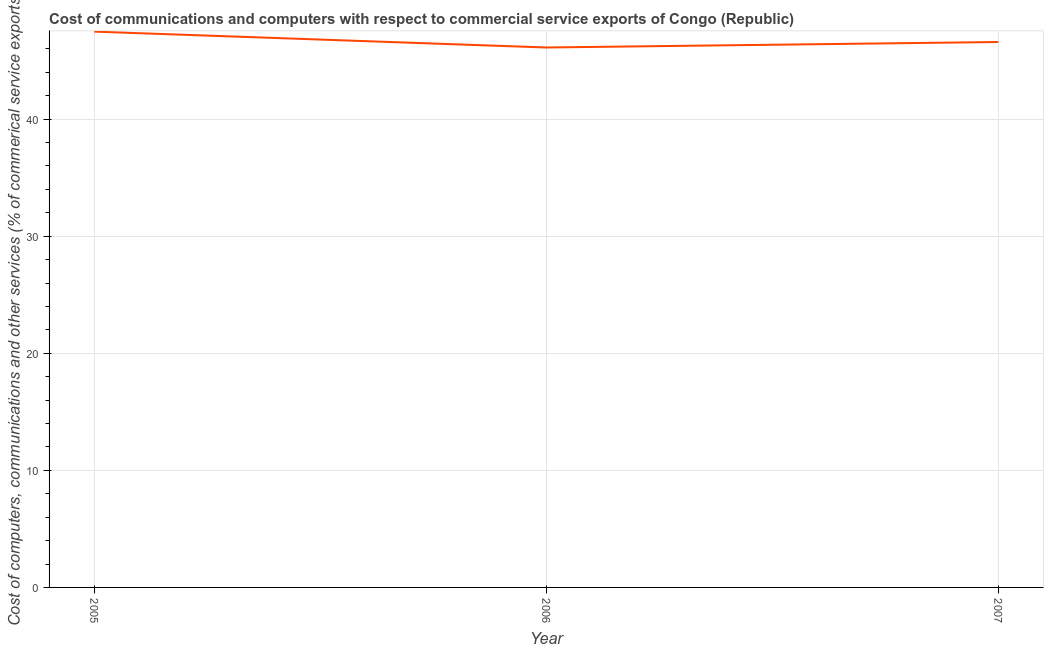What is the  computer and other services in 2007?
Give a very brief answer. 46.59. Across all years, what is the maximum  computer and other services?
Ensure brevity in your answer.  47.47. Across all years, what is the minimum  computer and other services?
Ensure brevity in your answer.  46.12. In which year was the  computer and other services maximum?
Offer a terse response. 2005. What is the sum of the  computer and other services?
Your answer should be compact. 140.18. What is the difference between the cost of communications in 2005 and 2006?
Your answer should be compact. 1.36. What is the average cost of communications per year?
Provide a short and direct response. 46.73. What is the median  computer and other services?
Your answer should be compact. 46.59. In how many years, is the cost of communications greater than 28 %?
Give a very brief answer. 3. What is the ratio of the cost of communications in 2005 to that in 2006?
Your response must be concise. 1.03. Is the cost of communications in 2005 less than that in 2006?
Offer a very short reply. No. What is the difference between the highest and the second highest cost of communications?
Make the answer very short. 0.89. Is the sum of the  computer and other services in 2005 and 2006 greater than the maximum  computer and other services across all years?
Make the answer very short. Yes. What is the difference between the highest and the lowest  computer and other services?
Provide a short and direct response. 1.36. Does the  computer and other services monotonically increase over the years?
Keep it short and to the point. No. What is the difference between two consecutive major ticks on the Y-axis?
Make the answer very short. 10. Are the values on the major ticks of Y-axis written in scientific E-notation?
Make the answer very short. No. Does the graph contain any zero values?
Your answer should be compact. No. Does the graph contain grids?
Ensure brevity in your answer.  Yes. What is the title of the graph?
Provide a short and direct response. Cost of communications and computers with respect to commercial service exports of Congo (Republic). What is the label or title of the X-axis?
Your response must be concise. Year. What is the label or title of the Y-axis?
Provide a succinct answer. Cost of computers, communications and other services (% of commerical service exports). What is the Cost of computers, communications and other services (% of commerical service exports) in 2005?
Your response must be concise. 47.47. What is the Cost of computers, communications and other services (% of commerical service exports) of 2006?
Ensure brevity in your answer.  46.12. What is the Cost of computers, communications and other services (% of commerical service exports) of 2007?
Provide a succinct answer. 46.59. What is the difference between the Cost of computers, communications and other services (% of commerical service exports) in 2005 and 2006?
Provide a short and direct response. 1.36. What is the difference between the Cost of computers, communications and other services (% of commerical service exports) in 2005 and 2007?
Offer a terse response. 0.89. What is the difference between the Cost of computers, communications and other services (% of commerical service exports) in 2006 and 2007?
Provide a succinct answer. -0.47. What is the ratio of the Cost of computers, communications and other services (% of commerical service exports) in 2005 to that in 2006?
Make the answer very short. 1.03. What is the ratio of the Cost of computers, communications and other services (% of commerical service exports) in 2005 to that in 2007?
Provide a succinct answer. 1.02. 